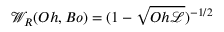<formula> <loc_0><loc_0><loc_500><loc_500>{ \mathcal { W } } _ { R } ( O h , B o ) = { ( 1 - \sqrt { O h { \ m a t h s c r { L } } } ) ^ { - 1 / 2 } }</formula> 